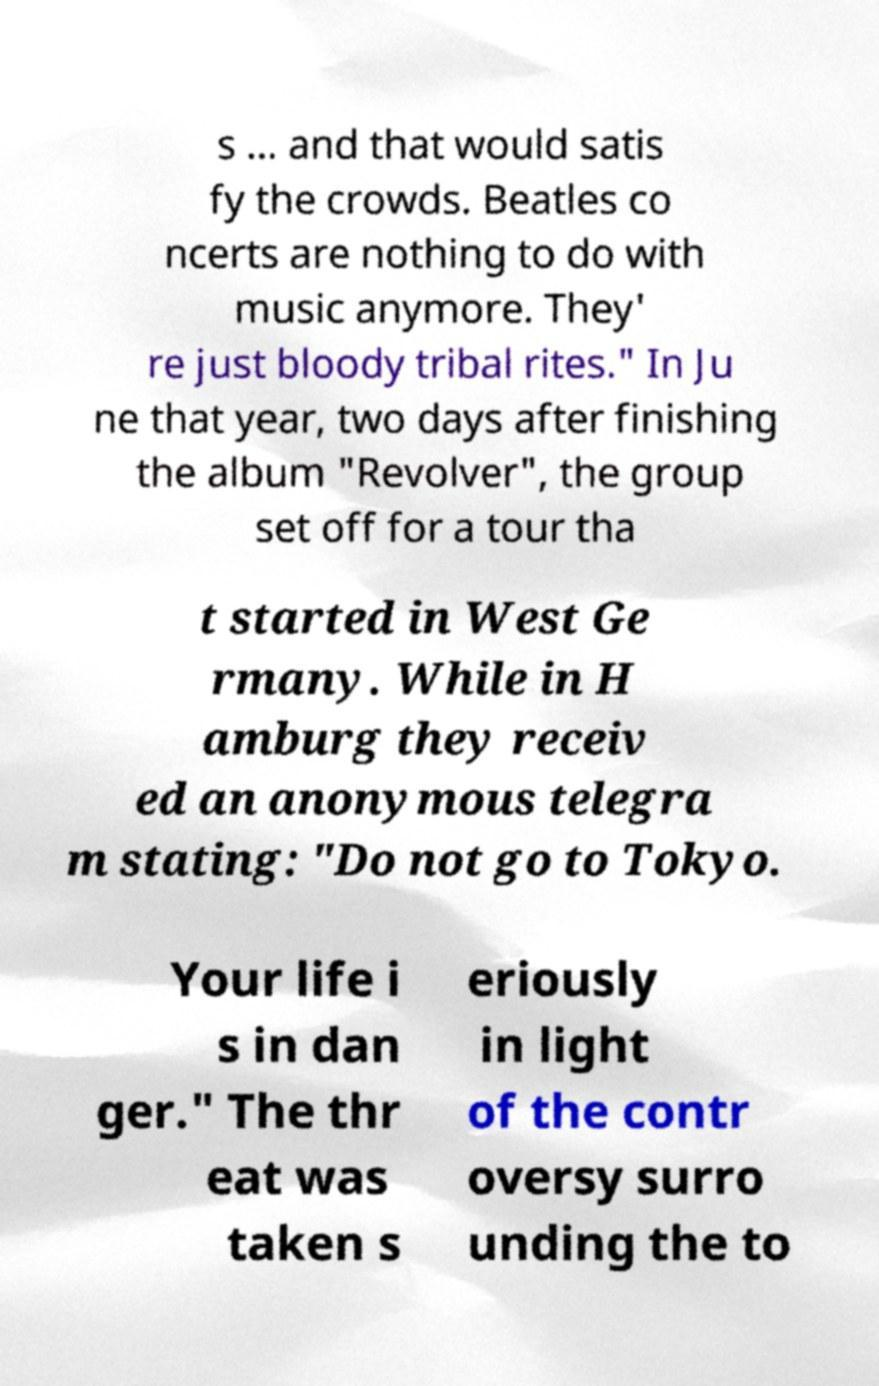Could you extract and type out the text from this image? s ... and that would satis fy the crowds. Beatles co ncerts are nothing to do with music anymore. They' re just bloody tribal rites." In Ju ne that year, two days after finishing the album "Revolver", the group set off for a tour tha t started in West Ge rmany. While in H amburg they receiv ed an anonymous telegra m stating: "Do not go to Tokyo. Your life i s in dan ger." The thr eat was taken s eriously in light of the contr oversy surro unding the to 